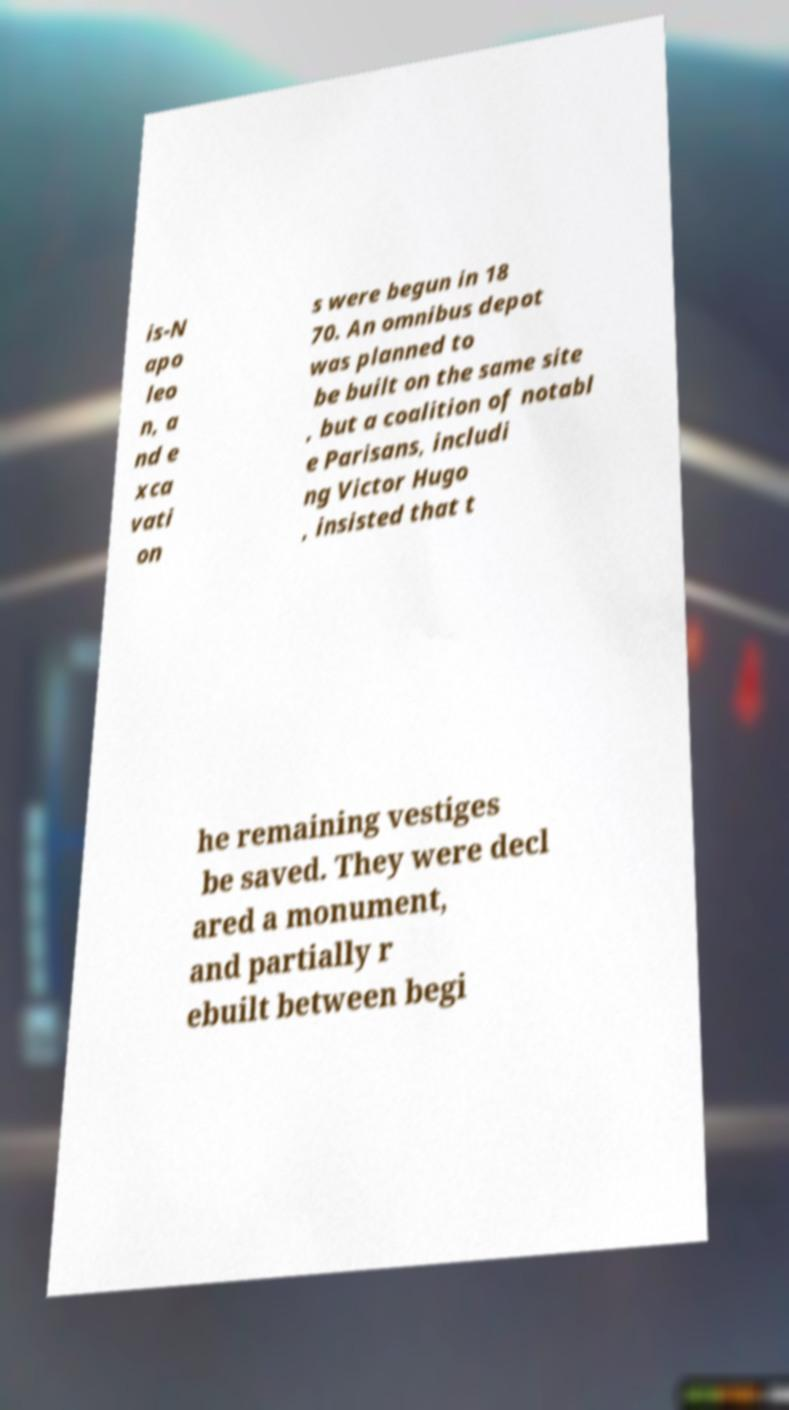What messages or text are displayed in this image? I need them in a readable, typed format. is-N apo leo n, a nd e xca vati on s were begun in 18 70. An omnibus depot was planned to be built on the same site , but a coalition of notabl e Parisans, includi ng Victor Hugo , insisted that t he remaining vestiges be saved. They were decl ared a monument, and partially r ebuilt between begi 